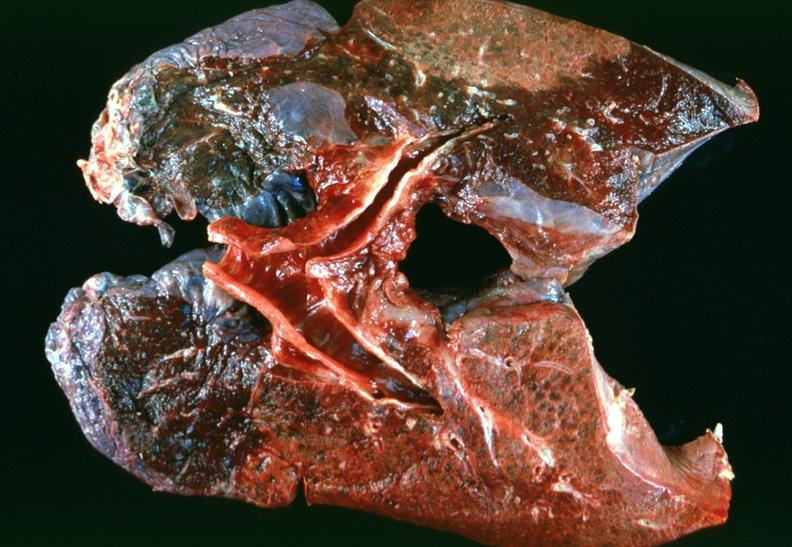what does this image show?
Answer the question using a single word or phrase. Lung 